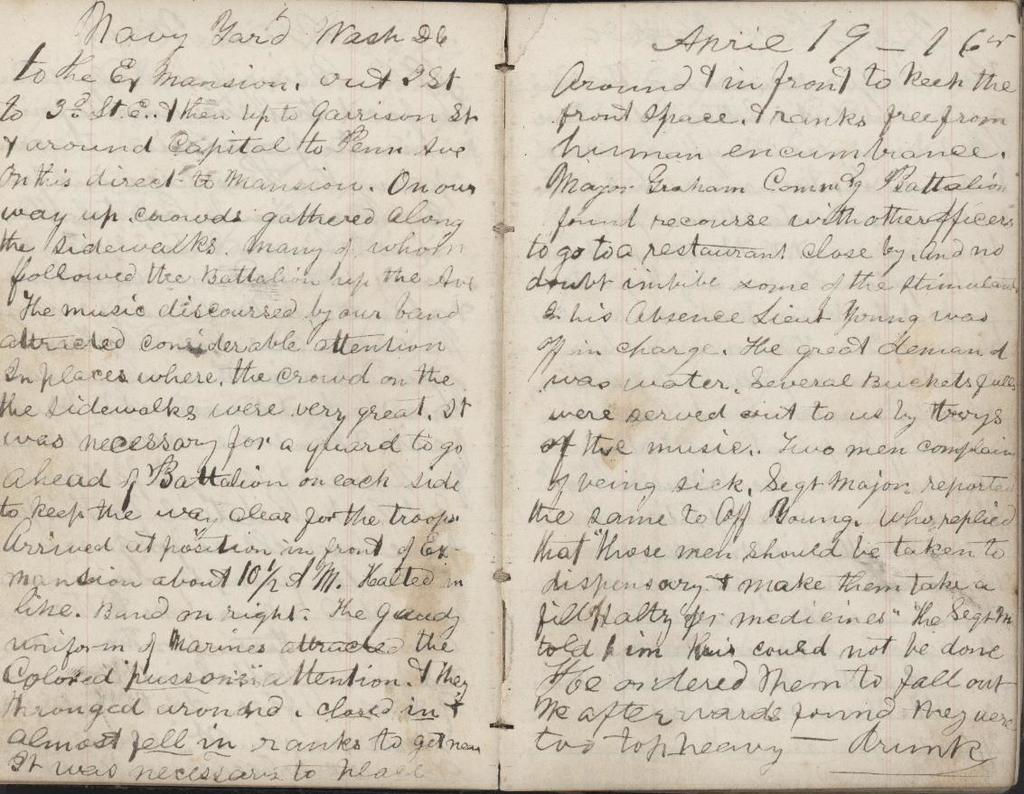What is the last word of the last page?
Ensure brevity in your answer.  Drunk. Is this a collection of old letters?
Offer a terse response. Yes. 